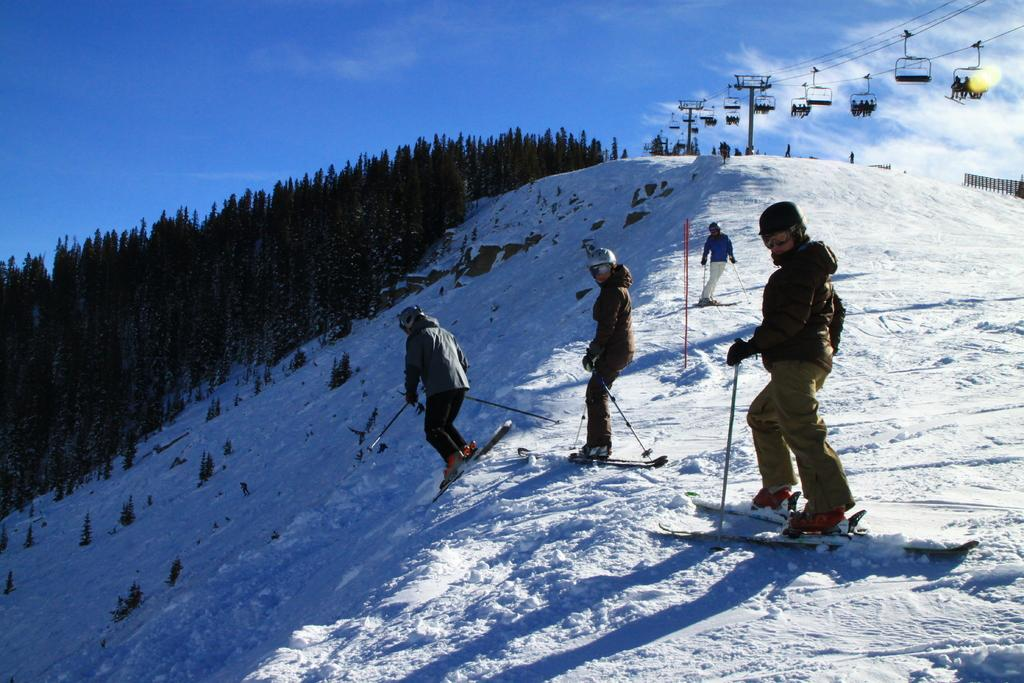What are the people in the image doing? The people in the image are standing on snowboards. What equipment are the people holding in the image? The people are holding ski sticks in the image. What can be seen in the background of the image? Ropeways and trees are present in the image. What is visible at the top of the image? The sky is visible at the top of the image. What statement is being made by the birthday cake in the image? There is no birthday cake present in the image. How does the roll of fabric move around in the image? There is no roll of fabric present in the image. 